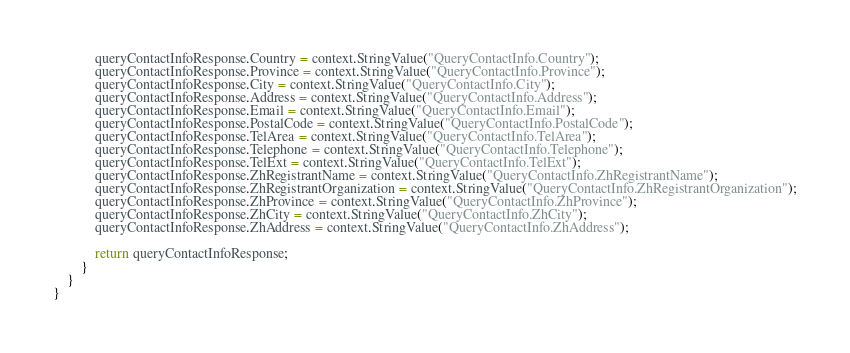Convert code to text. <code><loc_0><loc_0><loc_500><loc_500><_C#_>			queryContactInfoResponse.Country = context.StringValue("QueryContactInfo.Country");
			queryContactInfoResponse.Province = context.StringValue("QueryContactInfo.Province");
			queryContactInfoResponse.City = context.StringValue("QueryContactInfo.City");
			queryContactInfoResponse.Address = context.StringValue("QueryContactInfo.Address");
			queryContactInfoResponse.Email = context.StringValue("QueryContactInfo.Email");
			queryContactInfoResponse.PostalCode = context.StringValue("QueryContactInfo.PostalCode");
			queryContactInfoResponse.TelArea = context.StringValue("QueryContactInfo.TelArea");
			queryContactInfoResponse.Telephone = context.StringValue("QueryContactInfo.Telephone");
			queryContactInfoResponse.TelExt = context.StringValue("QueryContactInfo.TelExt");
			queryContactInfoResponse.ZhRegistrantName = context.StringValue("QueryContactInfo.ZhRegistrantName");
			queryContactInfoResponse.ZhRegistrantOrganization = context.StringValue("QueryContactInfo.ZhRegistrantOrganization");
			queryContactInfoResponse.ZhProvince = context.StringValue("QueryContactInfo.ZhProvince");
			queryContactInfoResponse.ZhCity = context.StringValue("QueryContactInfo.ZhCity");
			queryContactInfoResponse.ZhAddress = context.StringValue("QueryContactInfo.ZhAddress");
        
			return queryContactInfoResponse;
        }
    }
}
</code> 